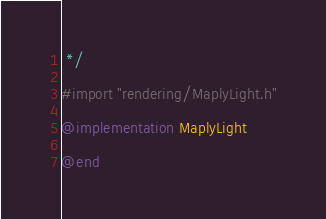Convert code to text. <code><loc_0><loc_0><loc_500><loc_500><_ObjectiveC_> */

#import "rendering/MaplyLight.h"

@implementation MaplyLight

@end
</code> 